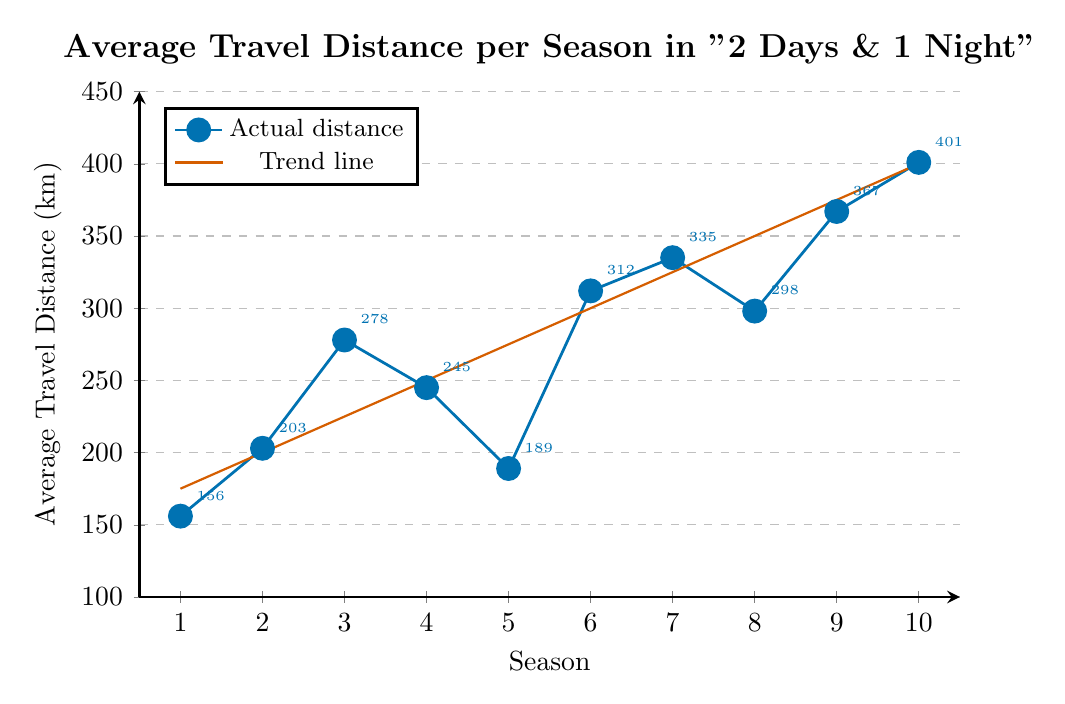What is the trend in average travel distance over the seasons? The figure visually shows increasing values over multiple seasons, indicating a rising trend in travel distance.
Answer: Increasing Which season has the highest average travel distance? By visually inspecting the data points on the y-axis, the highest mark is for Season 10.
Answer: Season 10 How does Season 4's travel distance compare to Season 3's? Season 3 has 278 km, and Season 4 has 245 km. 245 km is less than 278 km.
Answer: Season 4 has less than Season 3 Compute the average travel distance for the first five seasons. Sum the distances for Seasons 1 to 5 (156 + 203 + 278 + 245 + 189) = 1071, then divide by 5. 1071 / 5 = 214.2 km
Answer: 214.2 km Is the travel distance for Season 6 greater than the trend line prediction for that season? The travel distance for Season 6 is 312 km. According to the trend line, it's around 300 km. 312 km is greater than 300 km.
Answer: Yes What is the difference between the travel distances of Season 10 and Season 1? Subtract the travel distance of Season 1 from Season 10. 401 km - 156 km = 245 km.
Answer: 245 km Which seasons have average travel distances above 300 km? Visually identify data points above 300 km on y-axis: Season 6, Season 7, Season 8, Season 9, Season 10.
Answer: Seasons 6, 7, 8, 9, 10 By how much did the travel distance increase from Season 9 to Season 10? Subtract Season 9’s travel distance from Season 10’s. 401 km - 367 km = 34 km.
Answer: 34 km Calculate the median travel distance for all seasons. Arrange the values in order and find the middle value. Ordered distances: 156, 189, 203, 245, 278, 298, 312, 335, 367, 401. The median is the average of the 5th and 6th values: (278 + 298) / 2 = 288 km.
Answer: 288 km Does the actual travel distance for Season 2 exceed the trend line prediction? The travel distance for Season 2 is 203 km, and the trend line predicts approximately 200 km. 203 km is slightly greater than 200 km.
Answer: Yes 